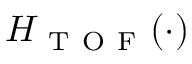<formula> <loc_0><loc_0><loc_500><loc_500>H _ { T O F } ( \cdot )</formula> 